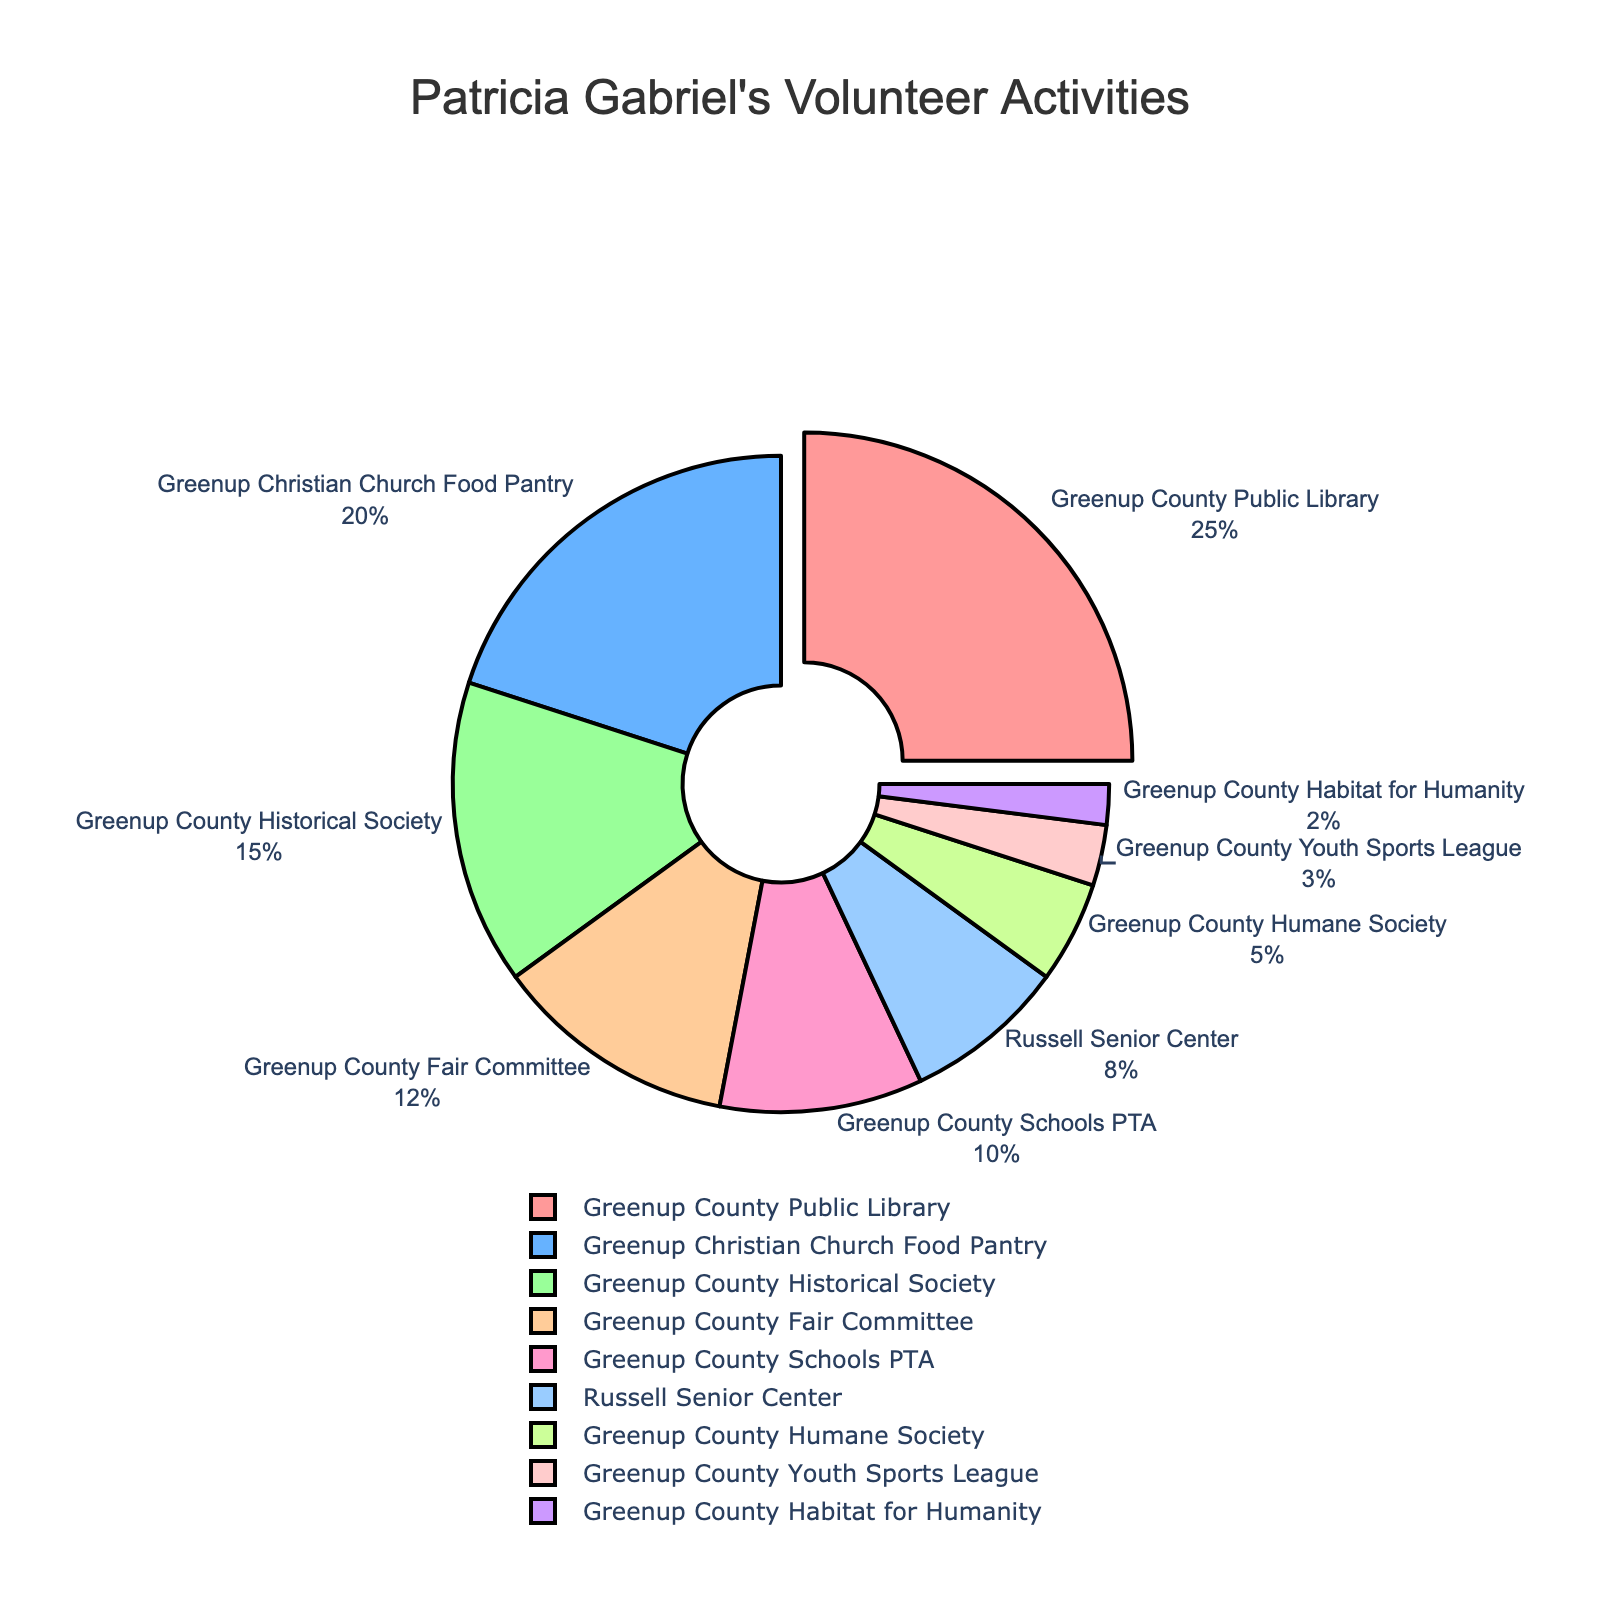Which activity did Patricia spend the most time on? Looking at the pie chart, the activity with the largest slice is the Greenup County Public Library with 25%.
Answer: Greenup County Public Library How does the percentage of time spent on the Greenup Christian Church Food Pantry compare to the Greenup County Fair Committee? The pie chart shows that the Greenup Christian Church Food Pantry occupies 20% while the Greenup County Fair Committee occupies 12%. Thus, the food pantry has a higher percentage.
Answer: The food pantry has a higher percentage Which activities collectively make up less than 10% of Patricia's time? The pie chart indicates that the Russell Senior Center (8%), Greenup County Humane Society (5%), Greenup County Youth Sports League (3%), and Greenup County Habitat for Humanity (2%) each have slices less than 10%.
Answer: Russell Senior Center, Greenup County Humane Society, Greenup County Youth Sports League, Greenup County Habitat for Humanity What percentage of Patricia's time is spent on Greenup County Schools PTA and Greenup County Historical Society combined? From the pie chart, the Greenup County Schools PTA is 10% and the Historical Society is 15%. Adding these, 10% + 15% = 25%.
Answer: 25% Which single activity has the smallest share of Patricia's volunteer time? From the pie chart, the smallest slice corresponds to the Greenup County Habitat for Humanity at 2%.
Answer: Greenup County Habitat for Humanity If we combine the percentages of time spent on community-related activities (library, food pantry, historical society, fair committee), what is the total? Community-related activities are represented by: Greenup County Public Library (25%) + Greenup Christian Church Food Pantry (20%) + Greenup County Historical Society (15%) + Greenup County Fair Committee (12%). Calculating the sum: 25% + 20% + 15% + 12% = 72%.
Answer: 72% What is the percentage difference between activities with the smallest and largest shares? The largest share is Greenup County Public Library at 25%, and the smallest is Greenup County Habitat for Humanity at 2%. The difference: 25% - 2% = 23%.
Answer: 23% 